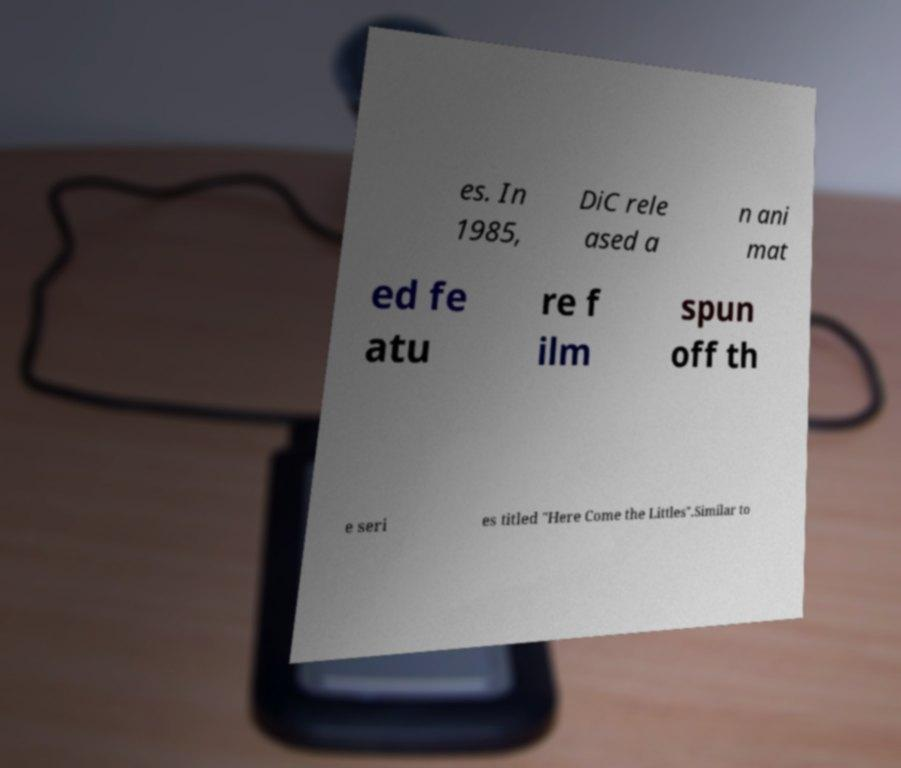Please identify and transcribe the text found in this image. es. In 1985, DiC rele ased a n ani mat ed fe atu re f ilm spun off th e seri es titled "Here Come the Littles".Similar to 